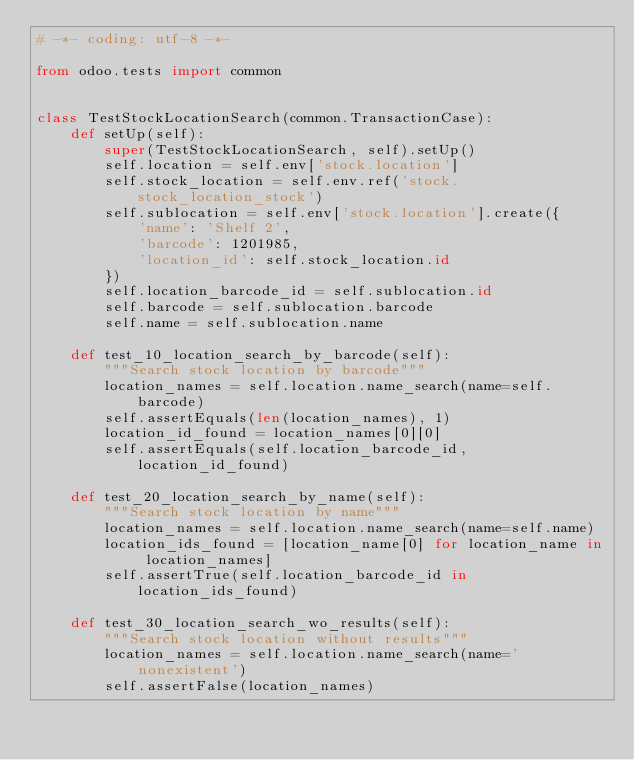Convert code to text. <code><loc_0><loc_0><loc_500><loc_500><_Python_># -*- coding: utf-8 -*-

from odoo.tests import common


class TestStockLocationSearch(common.TransactionCase):
    def setUp(self):
        super(TestStockLocationSearch, self).setUp()
        self.location = self.env['stock.location']
        self.stock_location = self.env.ref('stock.stock_location_stock')
        self.sublocation = self.env['stock.location'].create({
            'name': 'Shelf 2',
            'barcode': 1201985,
            'location_id': self.stock_location.id
        })
        self.location_barcode_id = self.sublocation.id
        self.barcode = self.sublocation.barcode
        self.name = self.sublocation.name

    def test_10_location_search_by_barcode(self):
        """Search stock location by barcode"""
        location_names = self.location.name_search(name=self.barcode)
        self.assertEquals(len(location_names), 1)
        location_id_found = location_names[0][0]
        self.assertEquals(self.location_barcode_id, location_id_found)

    def test_20_location_search_by_name(self):
        """Search stock location by name"""
        location_names = self.location.name_search(name=self.name)
        location_ids_found = [location_name[0] for location_name in location_names]
        self.assertTrue(self.location_barcode_id in location_ids_found)

    def test_30_location_search_wo_results(self):
        """Search stock location without results"""
        location_names = self.location.name_search(name='nonexistent')
        self.assertFalse(location_names)
</code> 